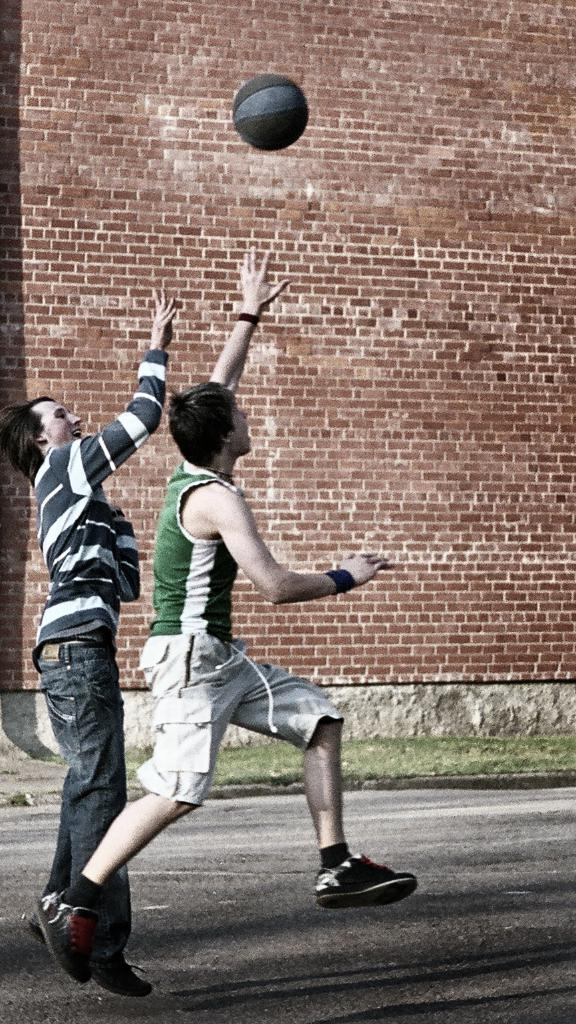How many people are in the image? There are two boys in the image. What are the boys doing in the image? The boys are playing with a ball. What can be seen in the background of the image? There is a brick wall in the background of the image. What is the purpose of the brass instrument in the image? There is no brass instrument present in the image. 